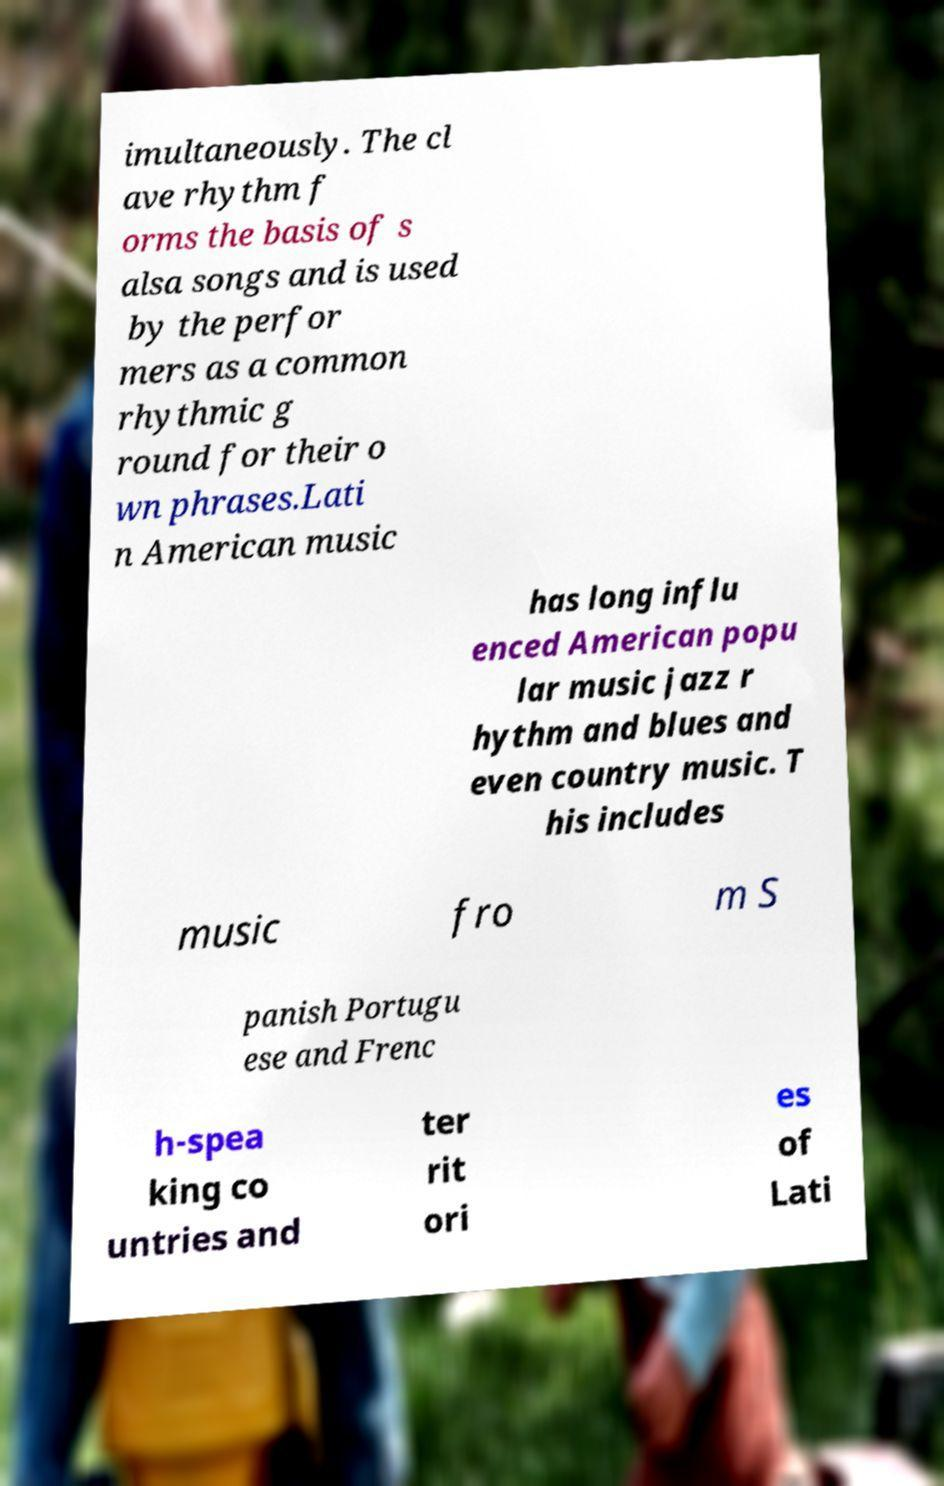Please identify and transcribe the text found in this image. imultaneously. The cl ave rhythm f orms the basis of s alsa songs and is used by the perfor mers as a common rhythmic g round for their o wn phrases.Lati n American music has long influ enced American popu lar music jazz r hythm and blues and even country music. T his includes music fro m S panish Portugu ese and Frenc h-spea king co untries and ter rit ori es of Lati 